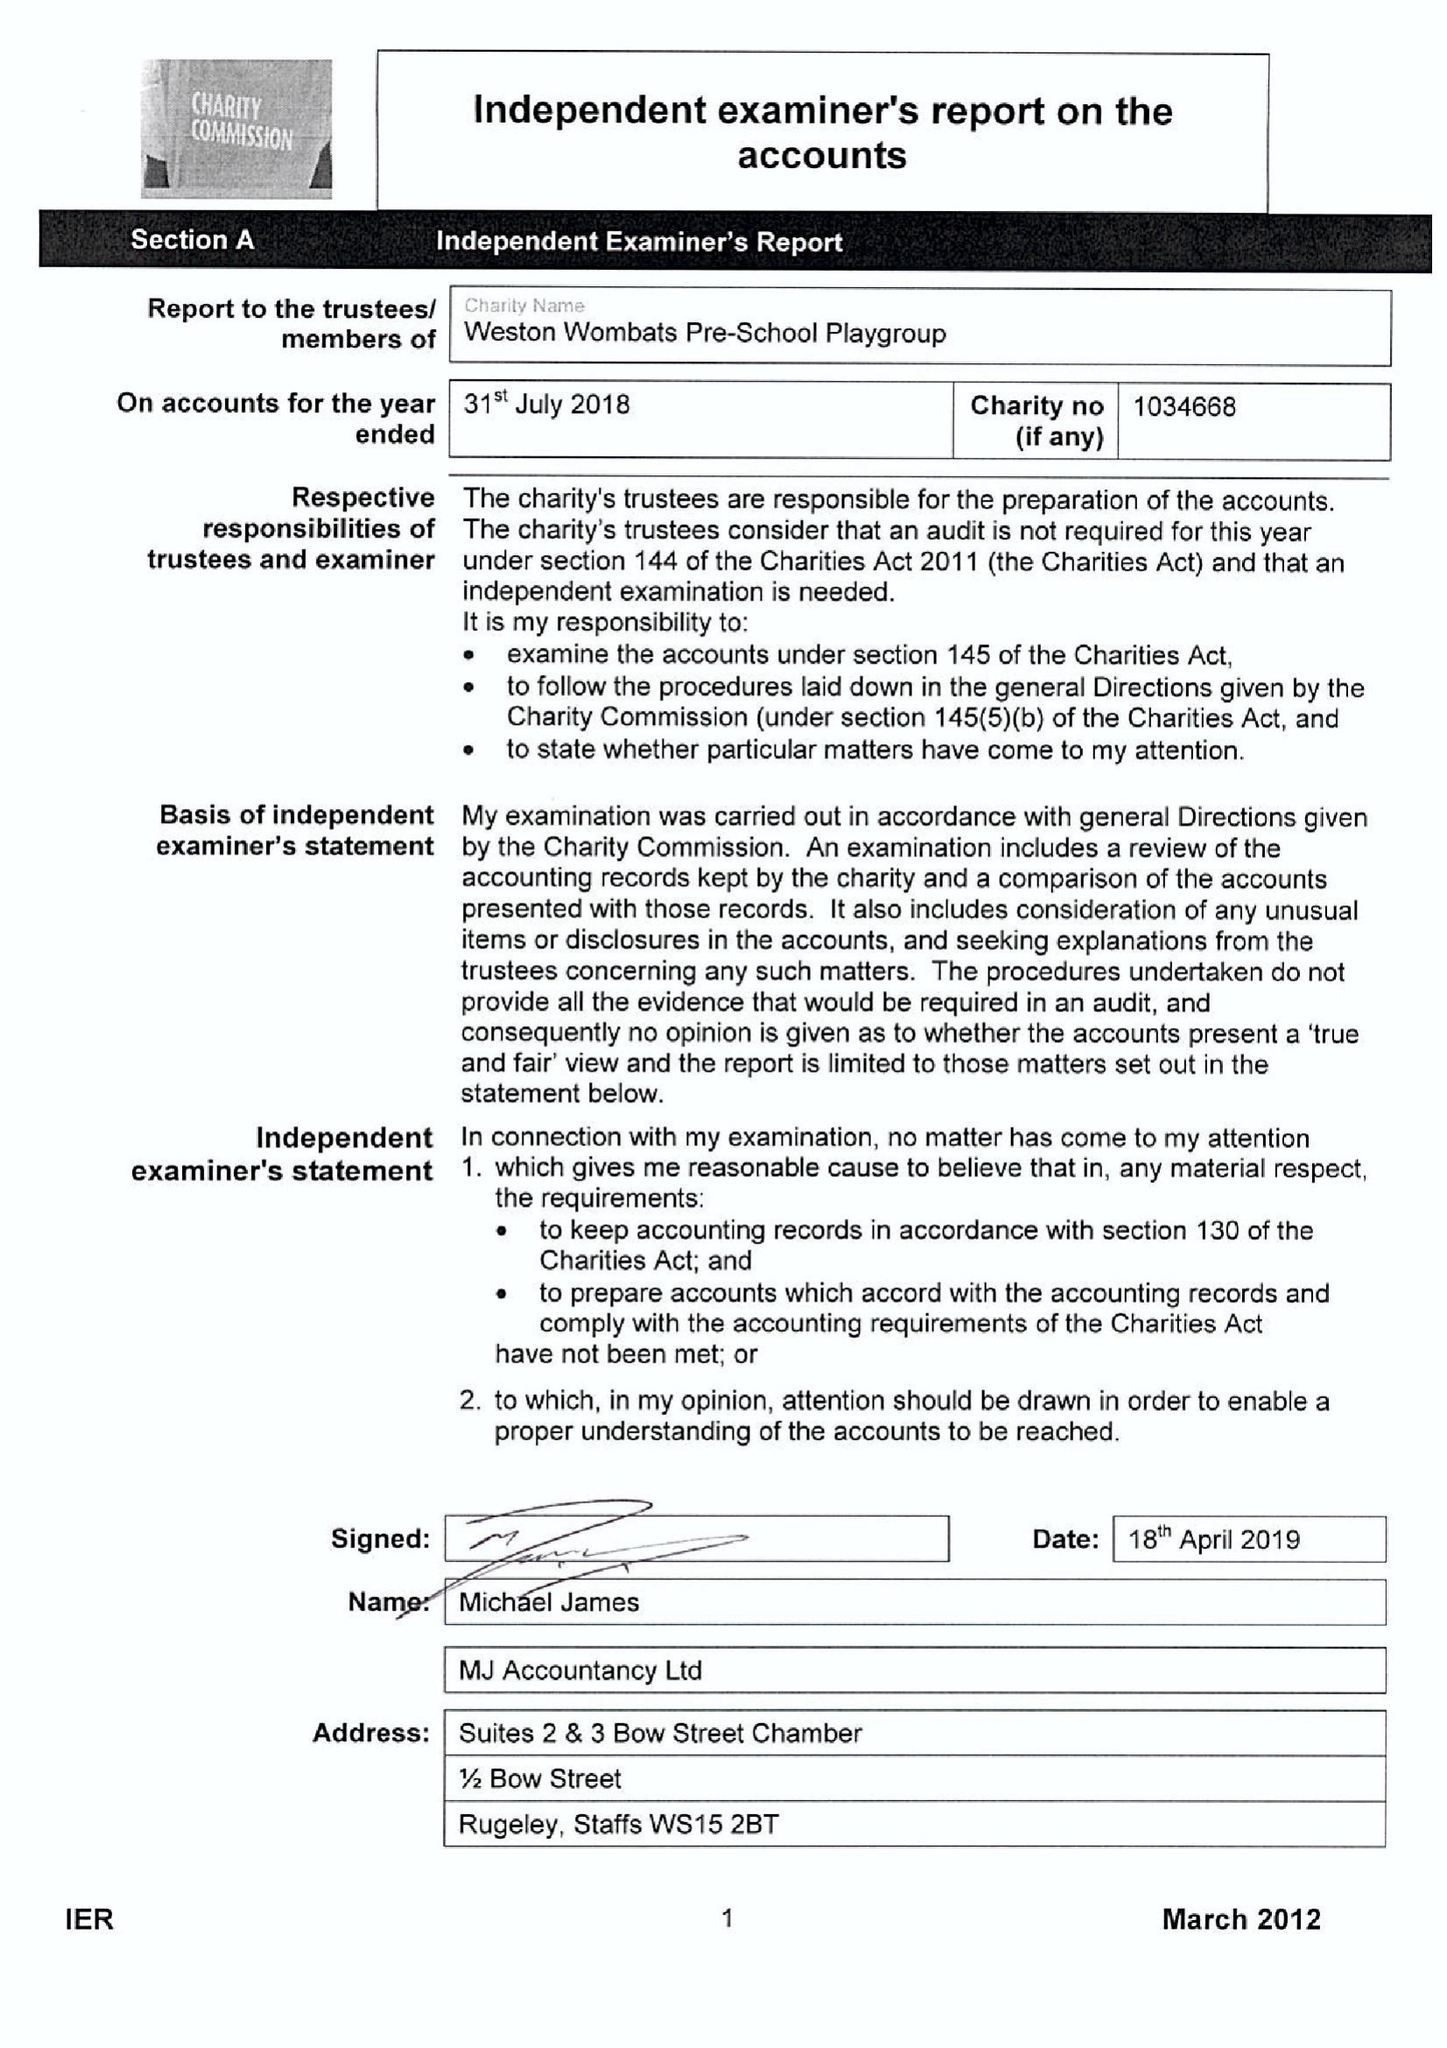What is the value for the address__post_town?
Answer the question using a single word or phrase. STAFFORD 